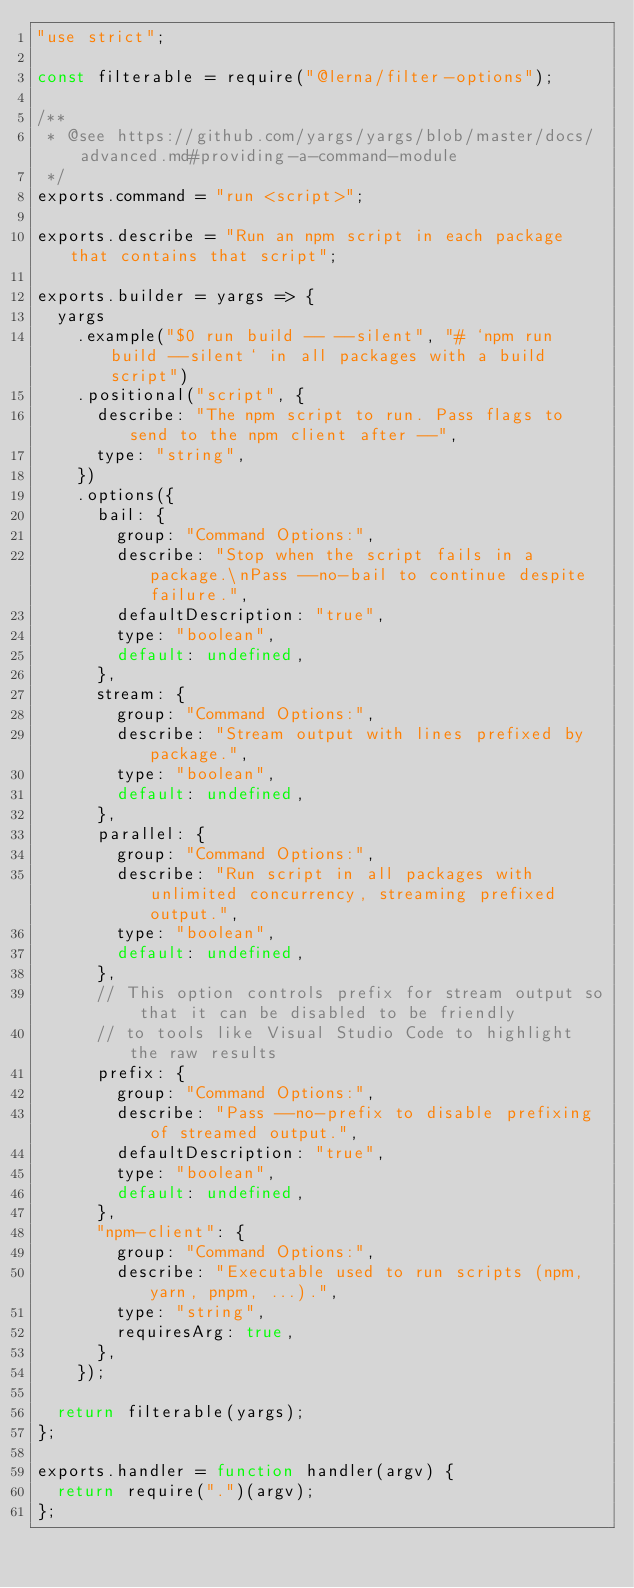<code> <loc_0><loc_0><loc_500><loc_500><_JavaScript_>"use strict";

const filterable = require("@lerna/filter-options");

/**
 * @see https://github.com/yargs/yargs/blob/master/docs/advanced.md#providing-a-command-module
 */
exports.command = "run <script>";

exports.describe = "Run an npm script in each package that contains that script";

exports.builder = yargs => {
  yargs
    .example("$0 run build -- --silent", "# `npm run build --silent` in all packages with a build script")
    .positional("script", {
      describe: "The npm script to run. Pass flags to send to the npm client after --",
      type: "string",
    })
    .options({
      bail: {
        group: "Command Options:",
        describe: "Stop when the script fails in a package.\nPass --no-bail to continue despite failure.",
        defaultDescription: "true",
        type: "boolean",
        default: undefined,
      },
      stream: {
        group: "Command Options:",
        describe: "Stream output with lines prefixed by package.",
        type: "boolean",
        default: undefined,
      },
      parallel: {
        group: "Command Options:",
        describe: "Run script in all packages with unlimited concurrency, streaming prefixed output.",
        type: "boolean",
        default: undefined,
      },
      // This option controls prefix for stream output so that it can be disabled to be friendly
      // to tools like Visual Studio Code to highlight the raw results
      prefix: {
        group: "Command Options:",
        describe: "Pass --no-prefix to disable prefixing of streamed output.",
        defaultDescription: "true",
        type: "boolean",
        default: undefined,
      },
      "npm-client": {
        group: "Command Options:",
        describe: "Executable used to run scripts (npm, yarn, pnpm, ...).",
        type: "string",
        requiresArg: true,
      },
    });

  return filterable(yargs);
};

exports.handler = function handler(argv) {
  return require(".")(argv);
};
</code> 